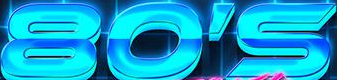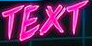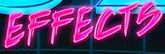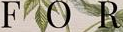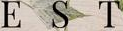Read the text from these images in sequence, separated by a semicolon. 80'S; TEXT; EFFECTS; FOR; EST 